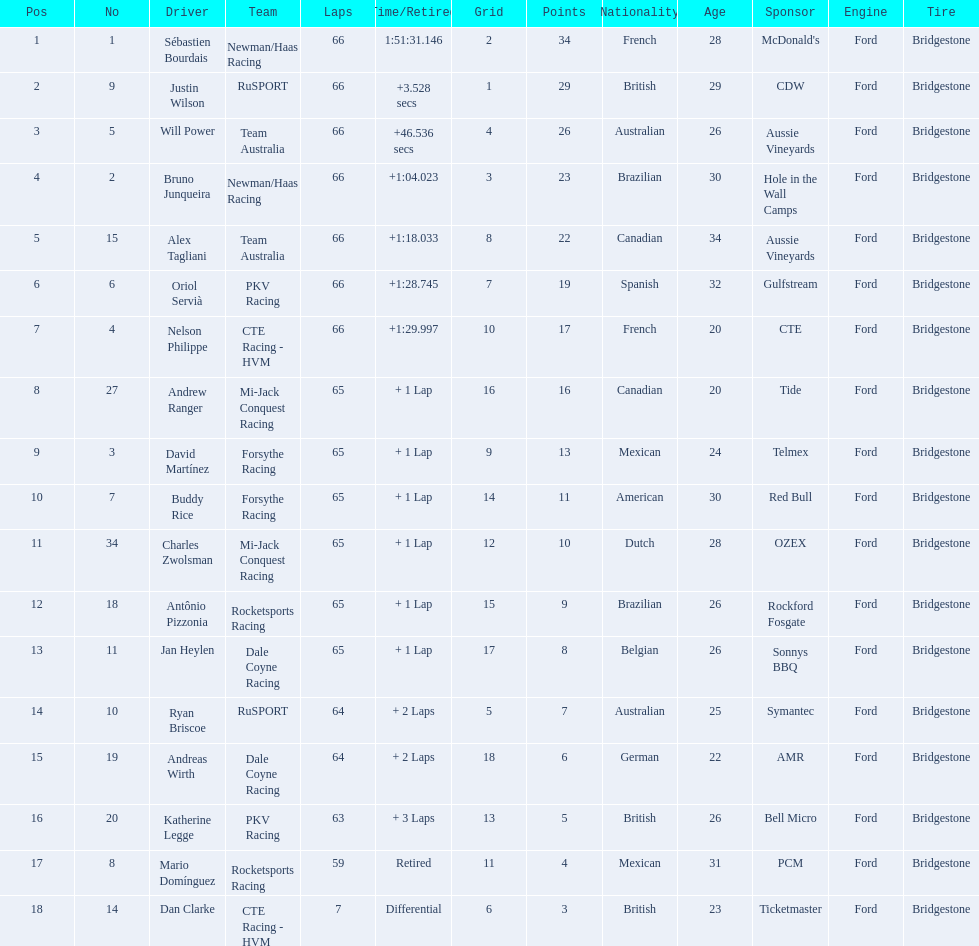How many points did first place receive? 34. How many did last place receive? 3. Who was the recipient of these last place points? Dan Clarke. 